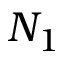<formula> <loc_0><loc_0><loc_500><loc_500>N _ { 1 }</formula> 